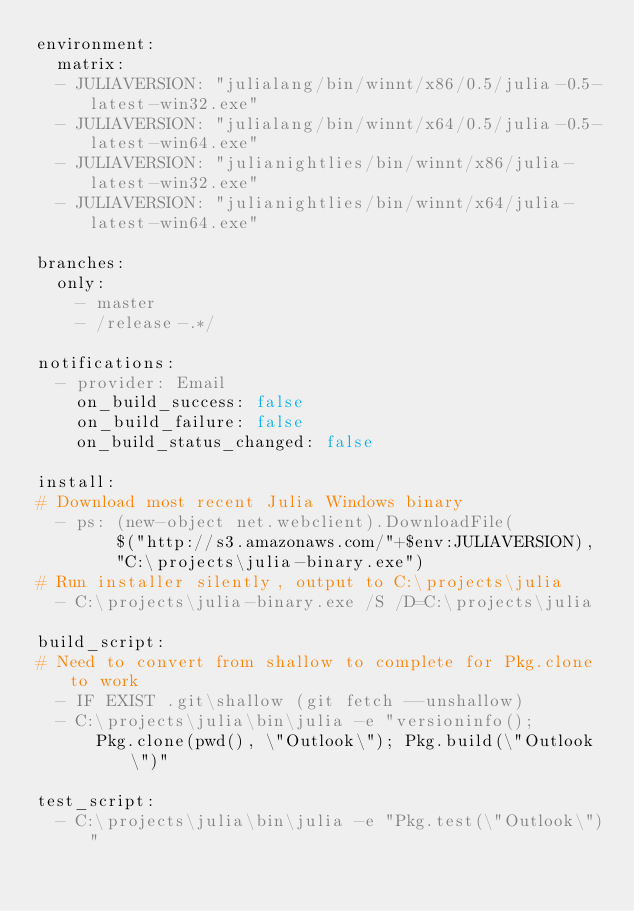<code> <loc_0><loc_0><loc_500><loc_500><_YAML_>environment:
  matrix:
  - JULIAVERSION: "julialang/bin/winnt/x86/0.5/julia-0.5-latest-win32.exe"
  - JULIAVERSION: "julialang/bin/winnt/x64/0.5/julia-0.5-latest-win64.exe"
  - JULIAVERSION: "julianightlies/bin/winnt/x86/julia-latest-win32.exe"
  - JULIAVERSION: "julianightlies/bin/winnt/x64/julia-latest-win64.exe"

branches:
  only:
    - master
    - /release-.*/

notifications:
  - provider: Email
    on_build_success: false
    on_build_failure: false
    on_build_status_changed: false

install:
# Download most recent Julia Windows binary
  - ps: (new-object net.webclient).DownloadFile(
        $("http://s3.amazonaws.com/"+$env:JULIAVERSION),
        "C:\projects\julia-binary.exe")
# Run installer silently, output to C:\projects\julia
  - C:\projects\julia-binary.exe /S /D=C:\projects\julia

build_script:
# Need to convert from shallow to complete for Pkg.clone to work
  - IF EXIST .git\shallow (git fetch --unshallow)
  - C:\projects\julia\bin\julia -e "versioninfo();
      Pkg.clone(pwd(), \"Outlook\"); Pkg.build(\"Outlook\")"

test_script:
  - C:\projects\julia\bin\julia -e "Pkg.test(\"Outlook\")"
</code> 